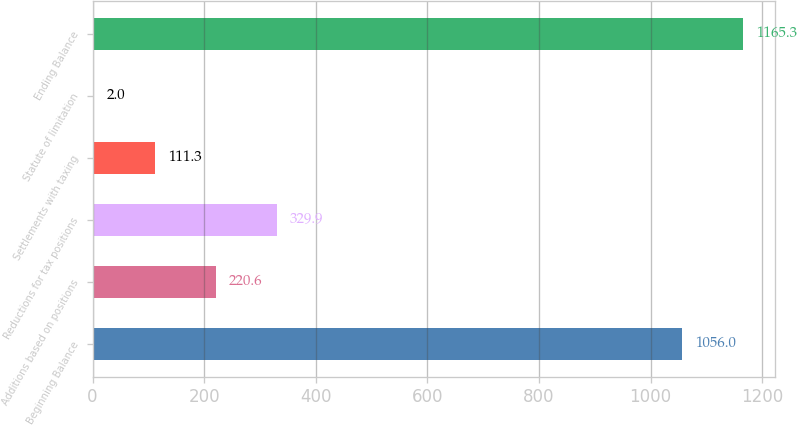Convert chart to OTSL. <chart><loc_0><loc_0><loc_500><loc_500><bar_chart><fcel>Beginning Balance<fcel>Additions based on positions<fcel>Reductions for tax positions<fcel>Settlements with taxing<fcel>Statute of limitation<fcel>Ending Balance<nl><fcel>1056<fcel>220.6<fcel>329.9<fcel>111.3<fcel>2<fcel>1165.3<nl></chart> 